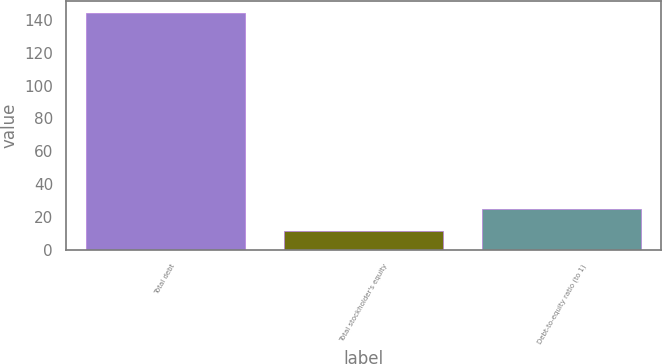Convert chart. <chart><loc_0><loc_0><loc_500><loc_500><bar_chart><fcel>Total debt<fcel>Total stockholder's equity<fcel>Debt-to-equity ratio (to 1)<nl><fcel>144.3<fcel>11.5<fcel>24.78<nl></chart> 